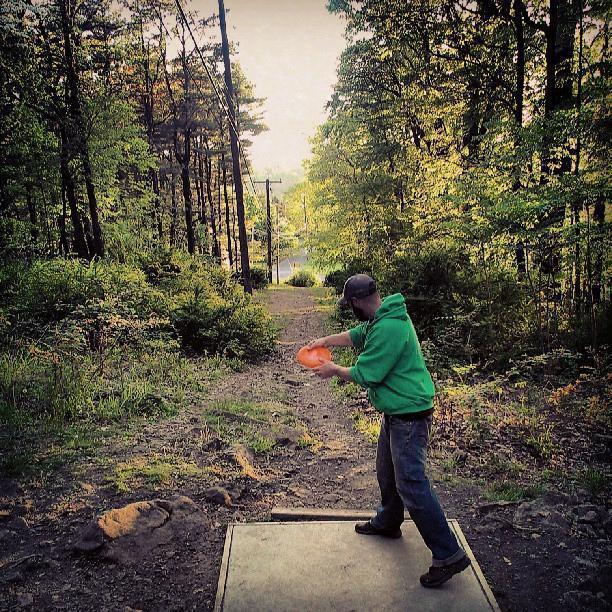The ground that the man is standing on is made of what material?
From the following four choices, select the correct answer to address the question.
Options: Cement, wood, ceramic, soil. Cement. 